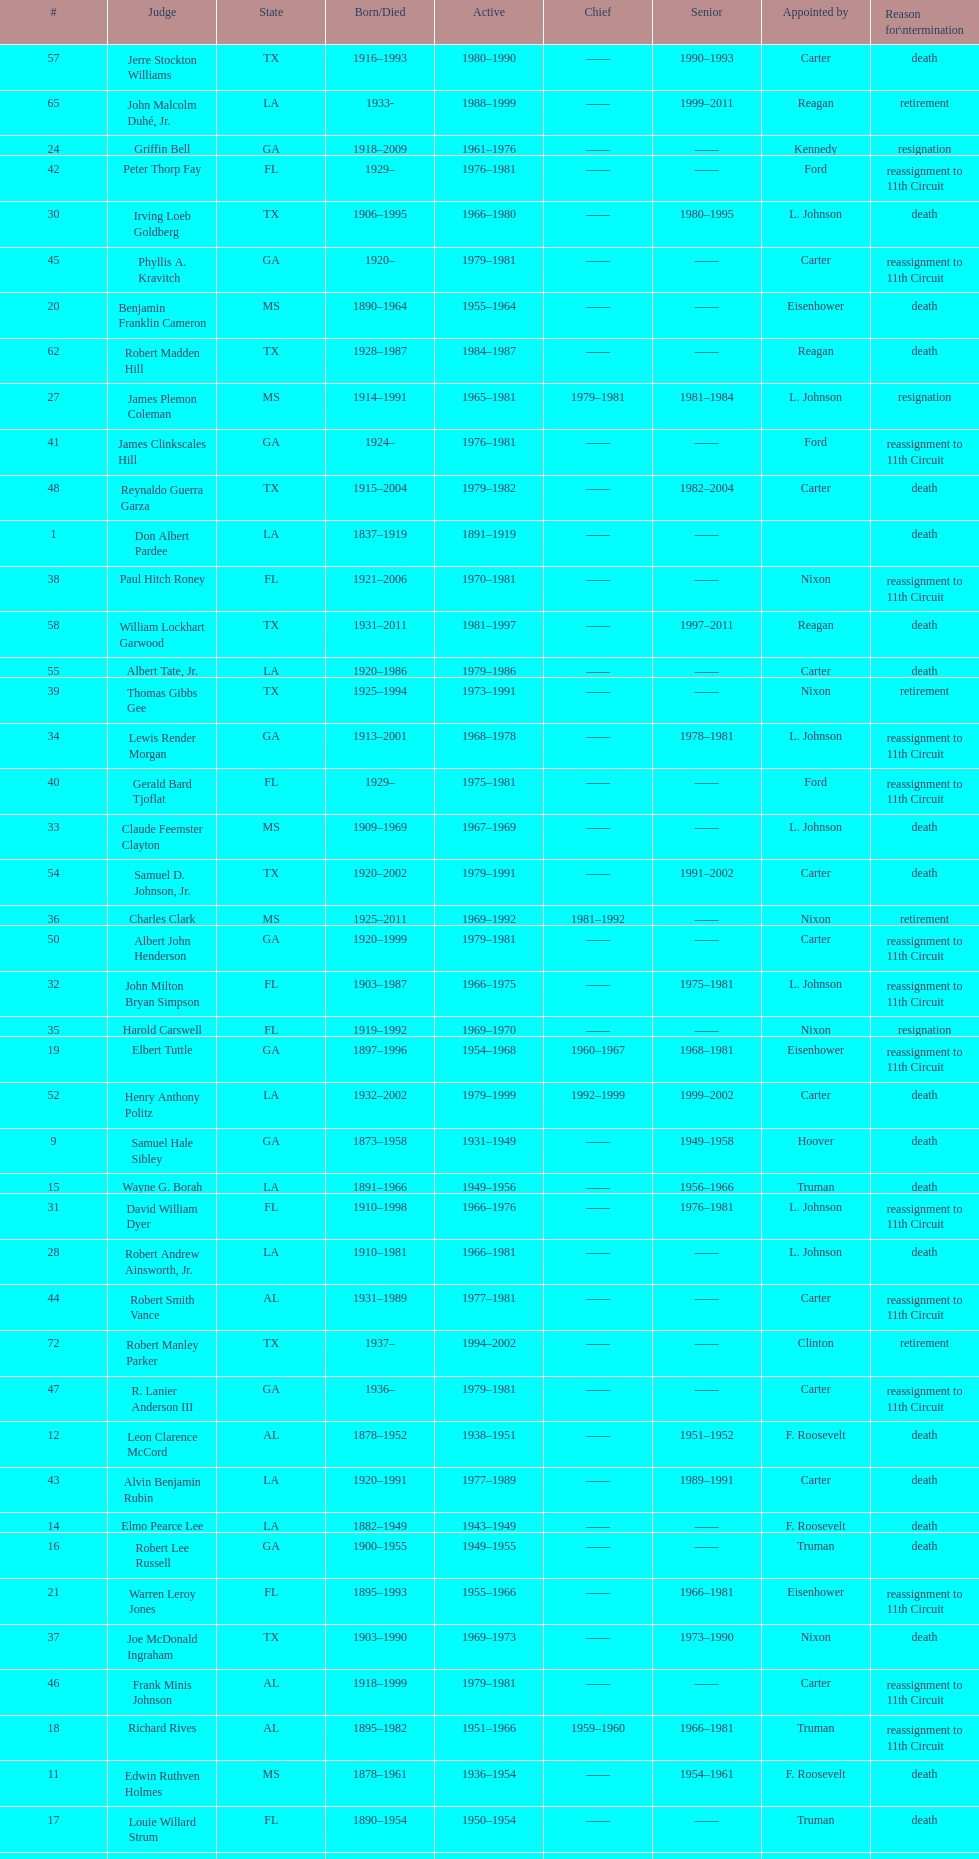Name a state listed at least 4 times. TX. 